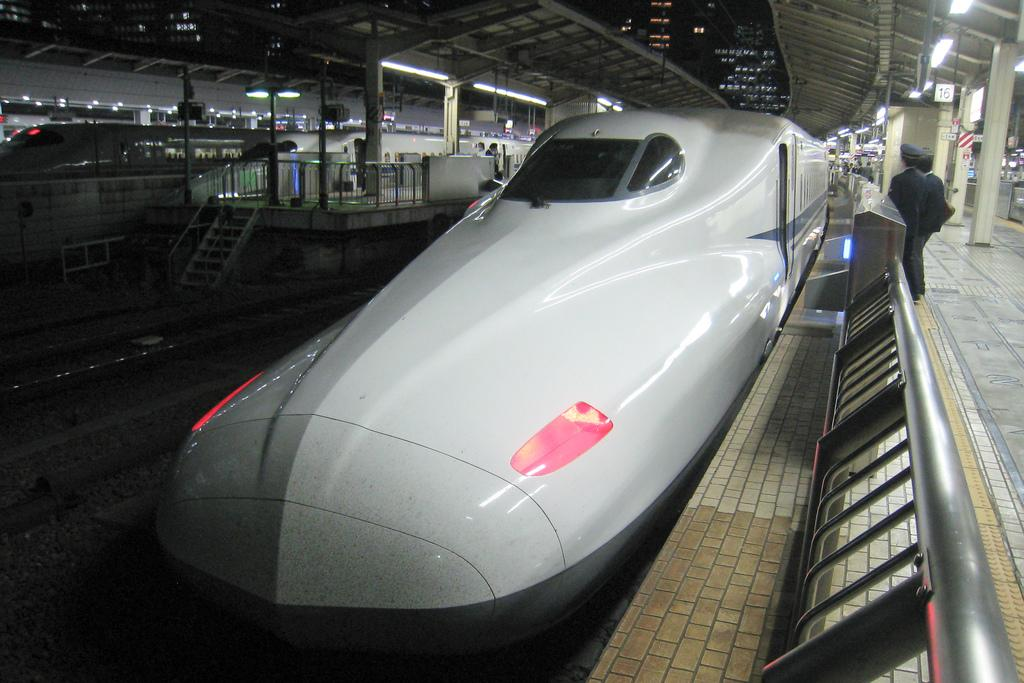What type of vehicles can be seen in the image? There are trains in the image. What can be seen illuminating the area in the image? There are lights in the image. Are there any people present in the image? Yes, there are people in the image. What type of architectural elements can be seen in the image? There are pillars, boards, a light pole, steps, railings, a platform, and a roof in the image. How does the image show the process of increasing the number of trains? The image does not show any process of increasing the number of trains; it simply depicts trains that are already present. 